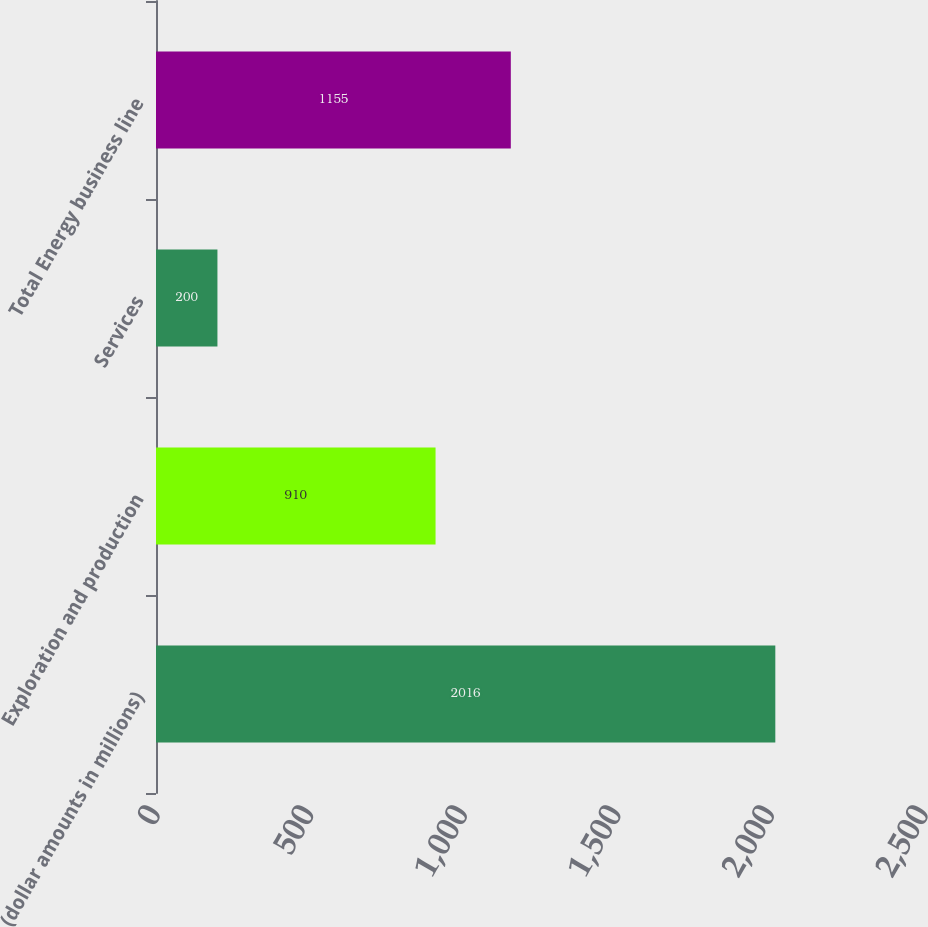Convert chart. <chart><loc_0><loc_0><loc_500><loc_500><bar_chart><fcel>(dollar amounts in millions)<fcel>Exploration and production<fcel>Services<fcel>Total Energy business line<nl><fcel>2016<fcel>910<fcel>200<fcel>1155<nl></chart> 